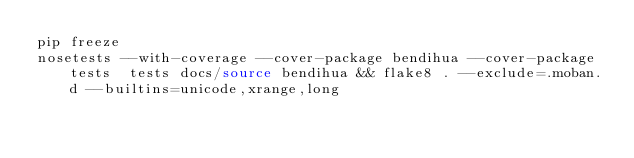Convert code to text. <code><loc_0><loc_0><loc_500><loc_500><_Bash_>pip freeze
nosetests --with-coverage --cover-package bendihua --cover-package tests  tests docs/source bendihua && flake8 . --exclude=.moban.d --builtins=unicode,xrange,long
</code> 